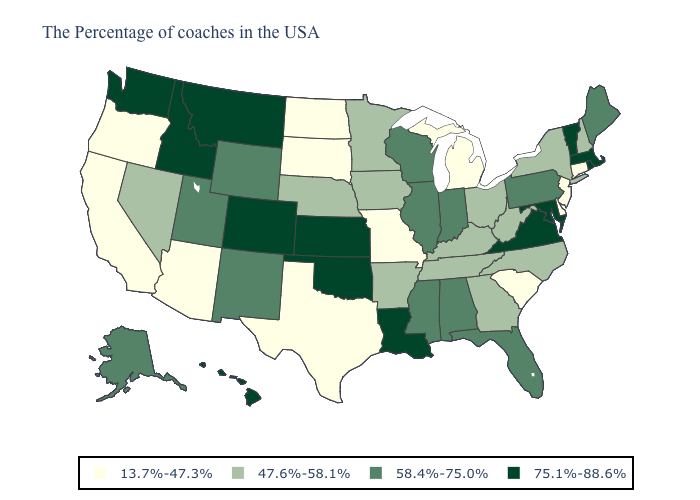What is the lowest value in the USA?
Keep it brief. 13.7%-47.3%. Name the states that have a value in the range 47.6%-58.1%?
Be succinct. New Hampshire, New York, North Carolina, West Virginia, Ohio, Georgia, Kentucky, Tennessee, Arkansas, Minnesota, Iowa, Nebraska, Nevada. Which states hav the highest value in the South?
Give a very brief answer. Maryland, Virginia, Louisiana, Oklahoma. What is the lowest value in the USA?
Write a very short answer. 13.7%-47.3%. Does Washington have the same value as New Hampshire?
Answer briefly. No. Among the states that border Utah , does Wyoming have the highest value?
Keep it brief. No. What is the value of South Dakota?
Write a very short answer. 13.7%-47.3%. Which states have the highest value in the USA?
Short answer required. Massachusetts, Rhode Island, Vermont, Maryland, Virginia, Louisiana, Kansas, Oklahoma, Colorado, Montana, Idaho, Washington, Hawaii. What is the value of Arkansas?
Answer briefly. 47.6%-58.1%. Which states have the highest value in the USA?
Concise answer only. Massachusetts, Rhode Island, Vermont, Maryland, Virginia, Louisiana, Kansas, Oklahoma, Colorado, Montana, Idaho, Washington, Hawaii. Name the states that have a value in the range 47.6%-58.1%?
Answer briefly. New Hampshire, New York, North Carolina, West Virginia, Ohio, Georgia, Kentucky, Tennessee, Arkansas, Minnesota, Iowa, Nebraska, Nevada. What is the highest value in the West ?
Write a very short answer. 75.1%-88.6%. What is the value of Kentucky?
Give a very brief answer. 47.6%-58.1%. What is the highest value in the Northeast ?
Keep it brief. 75.1%-88.6%. Name the states that have a value in the range 13.7%-47.3%?
Concise answer only. Connecticut, New Jersey, Delaware, South Carolina, Michigan, Missouri, Texas, South Dakota, North Dakota, Arizona, California, Oregon. 